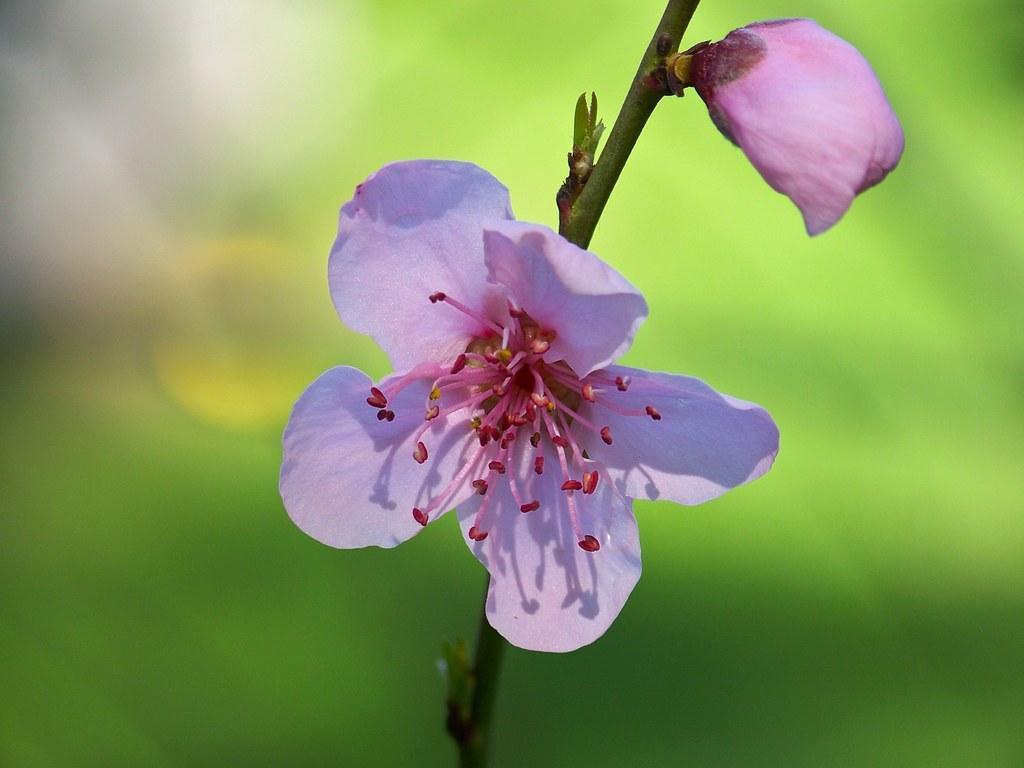Could you give a brief overview of what you see in this image? In this image we can see two flowers in pink color on the stem of a plant. 